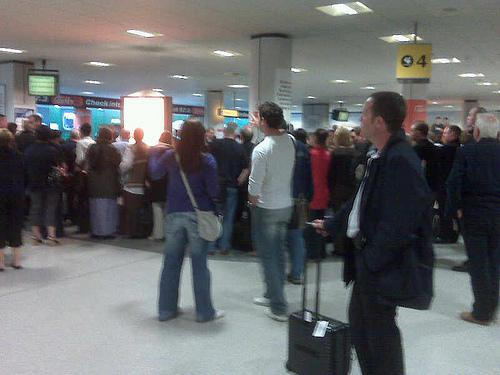Question: how would the person in immediate foreground operate the luggage?
Choices:
A. Pushing.
B. Using a cart.
C. By pulling.
D. Calling a bellhop.
Answer with the letter. Answer: C Question: what color does the man in foregrounds suit appear to be?
Choices:
A. Navy blue.
B. Black.
C. Green.
D. Orange.
Answer with the letter. Answer: A Question: why do all of these people appear to be here?
Choices:
A. Crying.
B. Walking.
C. Waiting in line.
D. On the phone.
Answer with the letter. Answer: C Question: who is the person in immediate forehand?
Choices:
A. Man.
B. A woman.
C. A child.
D. A grandma.
Answer with the letter. Answer: A Question: where could this photo have been taken?
Choices:
A. Mountains.
B. Ski resort.
C. Airport.
D. Kitchen.
Answer with the letter. Answer: C 